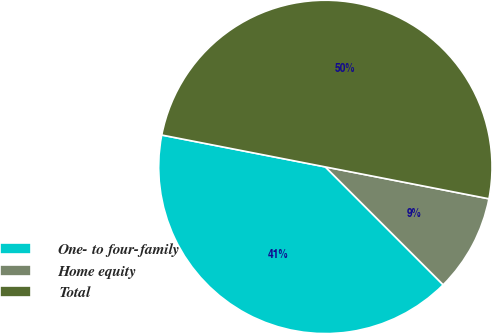Convert chart. <chart><loc_0><loc_0><loc_500><loc_500><pie_chart><fcel>One- to four-family<fcel>Home equity<fcel>Total<nl><fcel>40.56%<fcel>9.44%<fcel>50.0%<nl></chart> 